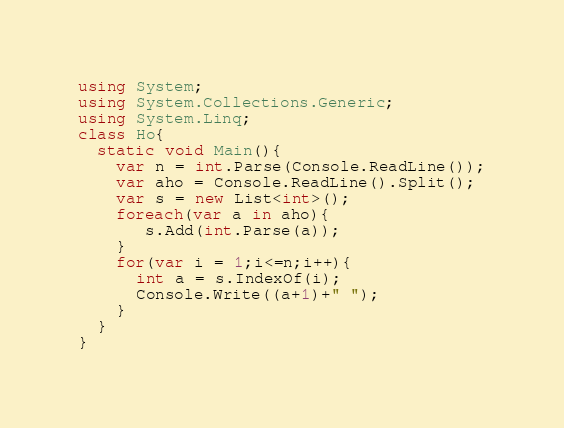Convert code to text. <code><loc_0><loc_0><loc_500><loc_500><_C#_>using System;
using System.Collections.Generic;
using System.Linq;
class Ho{
  static void Main(){
    var n = int.Parse(Console.ReadLine());
    var aho = Console.ReadLine().Split();
    var s = new List<int>();
    foreach(var a in aho){
       s.Add(int.Parse(a));
    }
    for(var i = 1;i<=n;i++){
      int a = s.IndexOf(i);
      Console.Write((a+1)+" ");
    }
  }
}</code> 